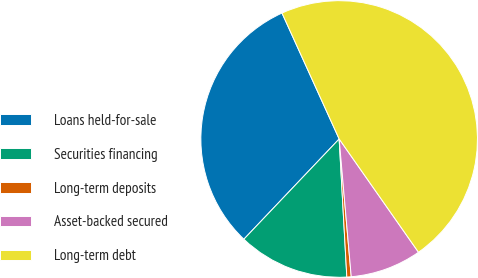<chart> <loc_0><loc_0><loc_500><loc_500><pie_chart><fcel>Loans held-for-sale<fcel>Securities financing<fcel>Long-term deposits<fcel>Asset-backed secured<fcel>Long-term debt<nl><fcel>31.12%<fcel>12.98%<fcel>0.51%<fcel>8.33%<fcel>47.06%<nl></chart> 